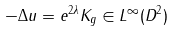<formula> <loc_0><loc_0><loc_500><loc_500>- \Delta u = e ^ { 2 \lambda } K _ { g } \in L ^ { \infty } ( D ^ { 2 } )</formula> 